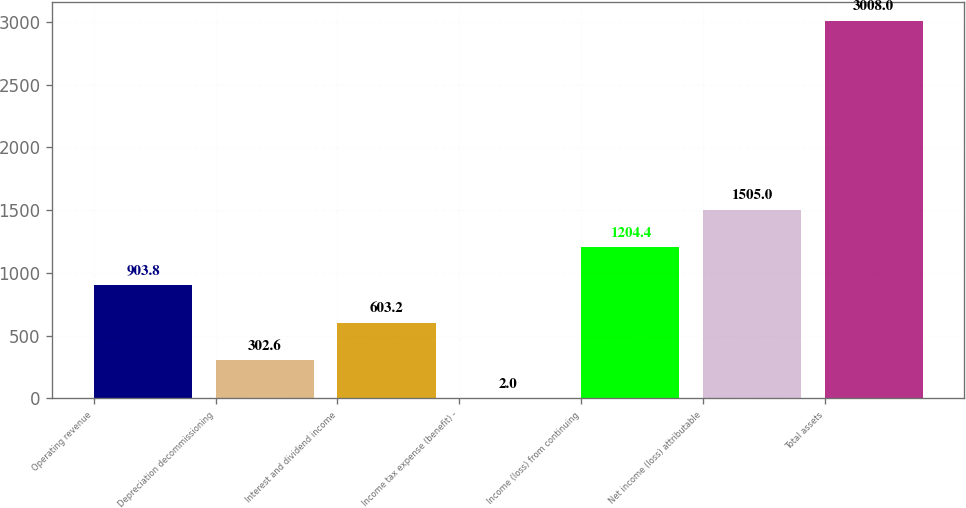Convert chart to OTSL. <chart><loc_0><loc_0><loc_500><loc_500><bar_chart><fcel>Operating revenue<fcel>Depreciation decommissioning<fcel>Interest and dividend income<fcel>Income tax expense (benefit) -<fcel>Income (loss) from continuing<fcel>Net income (loss) attributable<fcel>Total assets<nl><fcel>903.8<fcel>302.6<fcel>603.2<fcel>2<fcel>1204.4<fcel>1505<fcel>3008<nl></chart> 